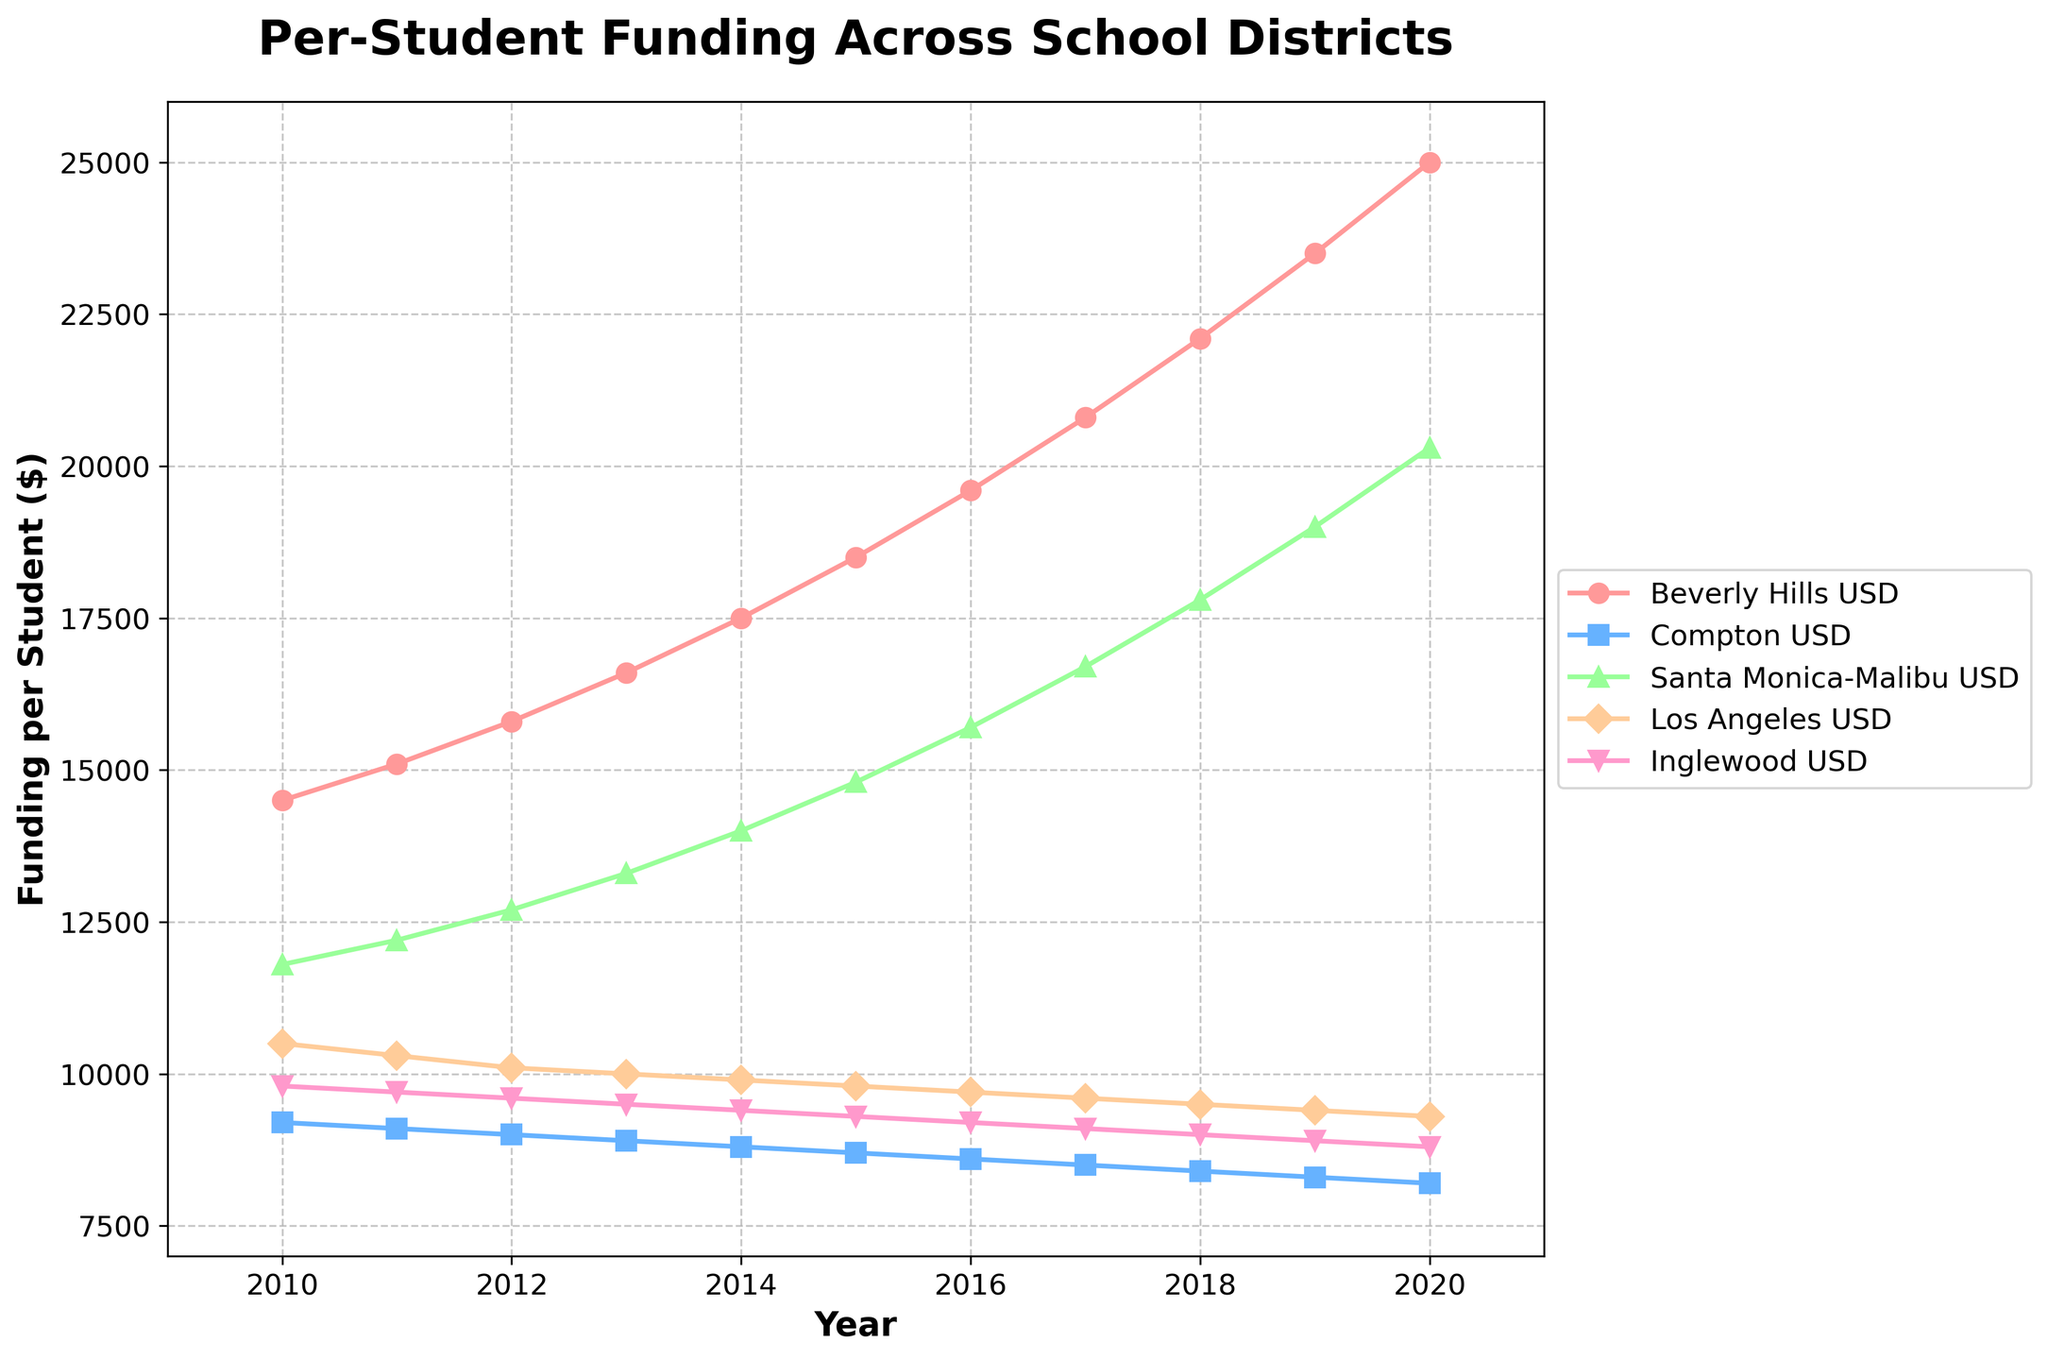What was the per-student funding in Los Angeles USD in 2015? Locate 2015 on the x-axis, then find the corresponding y-value for Los Angeles USD, denoted by the fourth plot marker.
Answer: 9800 How much difference in per-student funding was there between Beverly Hills USD and Compton USD in 2020? First, find the 2020 funding for both Beverly Hills USD (25000) and Compton USD (8200). Then subtract the lesser value from the greater value: 25000 - 8200.
Answer: 16800 Which school district experienced the highest increase in per-student funding from 2010 to 2020? Compare the funding amounts in 2010 and 2020 for all districts and calculate the difference for each. Beverly Hills USD (25000 - 14500 = 10500) has the largest increase.
Answer: Beverly Hills USD Did any school district see a decline in per-student funding over the years? Examine each district's funding trend from 2010 to 2020. All districts have an increasing trend, as no funding decreases year over year.
Answer: No In which year did Santa Monica-Malibu USD first surpass 15000 in per-student funding? Trace the line for Santa Monica-Malibu USD until it crosses the 15000 mark on the y-axis. This first occurs in 2016.
Answer: 2016 How does the growth rate of per-student funding in Inglewood USD compare to that in Beverly Hills USD between 2010 and 2020? Calculate the growth rates: (Inglewood USD: (8800 - 9800) / 9800 * 100 ≈ -10.20%; Beverly Hills USD: (25000 - 14500) / 14500 * 100 ≈ 72.41%). Beverly Hills USD has a significantly higher growth rate.
Answer: Beverly Hills USD grows faster What is the total per-student funding for all districts in 2015? Sum the per-student funding of all districts in 2015: 18500 + 8700 + 14800 + 9800 + 9300 = 61100.
Answer: 61100 In which year did Los Angeles USD and Inglewood USD both receive per-student funding of 9500? Identify the year where both funding amounts meet at 9500. This happened in 2017.
Answer: 2017 